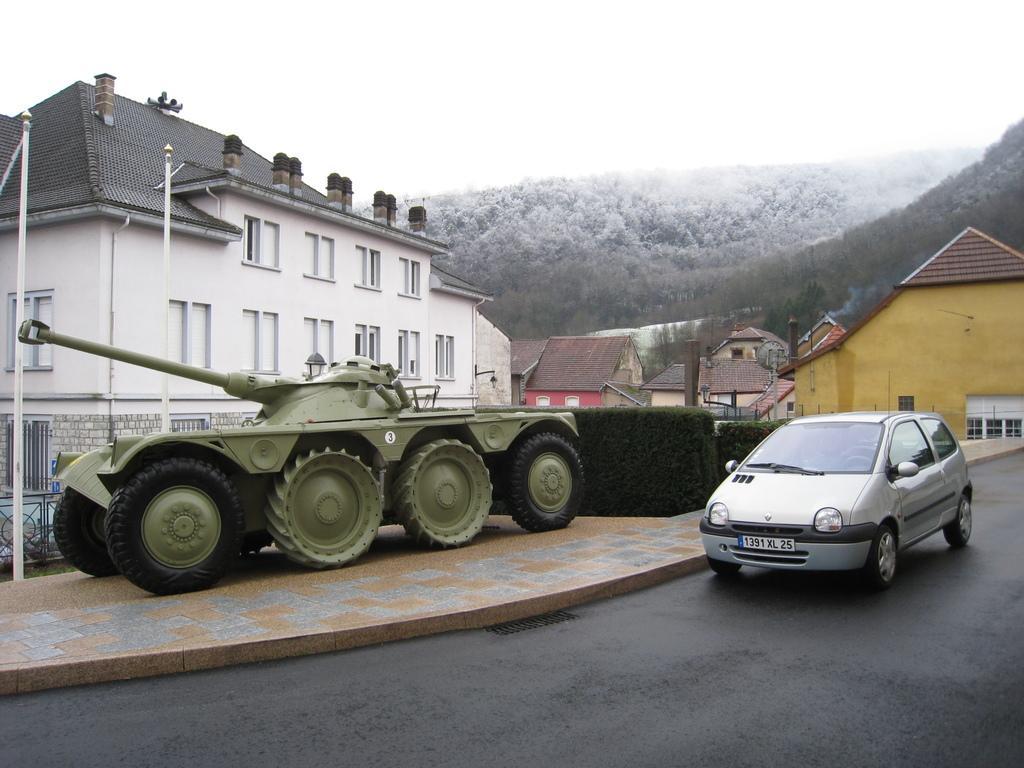How would you summarize this image in a sentence or two? In this image we can see a car and an armored car. In the background there are buildings, hills, sheds, hedge and sky. At the bottom there is a road. 